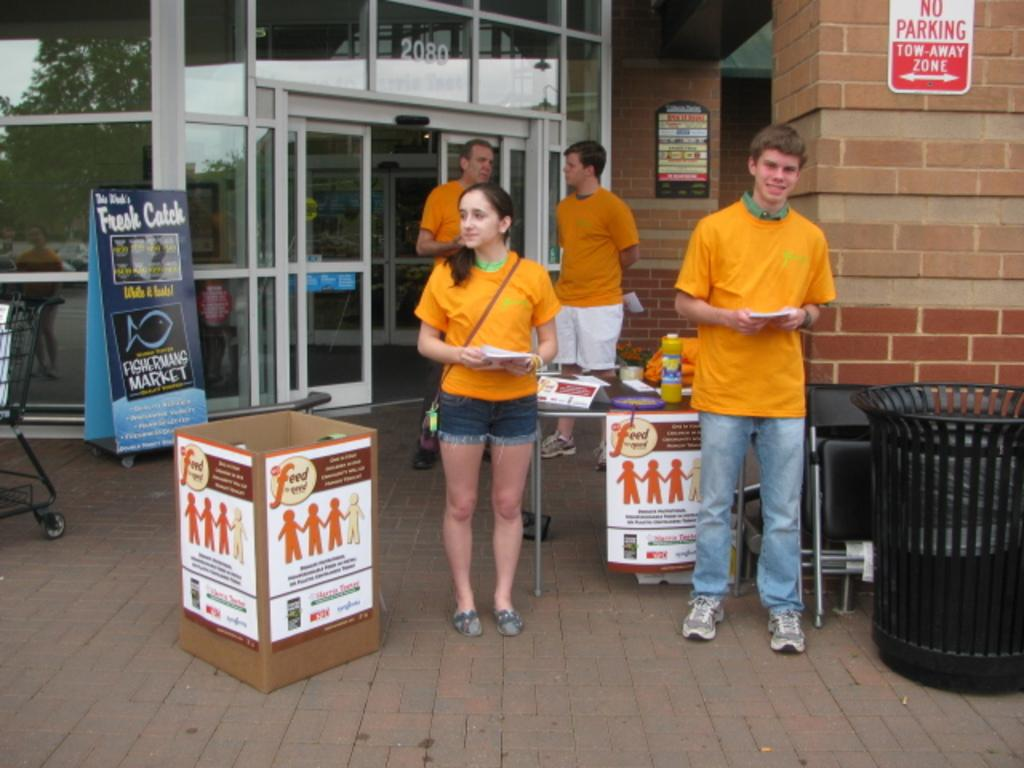<image>
Write a terse but informative summary of the picture. People standing in front of a sign which says "No Parking". 